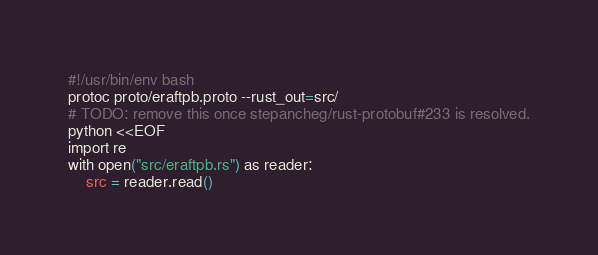<code> <loc_0><loc_0><loc_500><loc_500><_Bash_>#!/usr/bin/env bash
protoc proto/eraftpb.proto --rust_out=src/
# TODO: remove this once stepancheg/rust-protobuf#233 is resolved.
python <<EOF
import re
with open("src/eraftpb.rs") as reader:
    src = reader.read()
</code> 